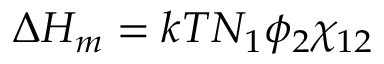Convert formula to latex. <formula><loc_0><loc_0><loc_500><loc_500>\Delta H _ { m } = k T N _ { 1 } \phi _ { 2 } \chi _ { 1 2 }</formula> 